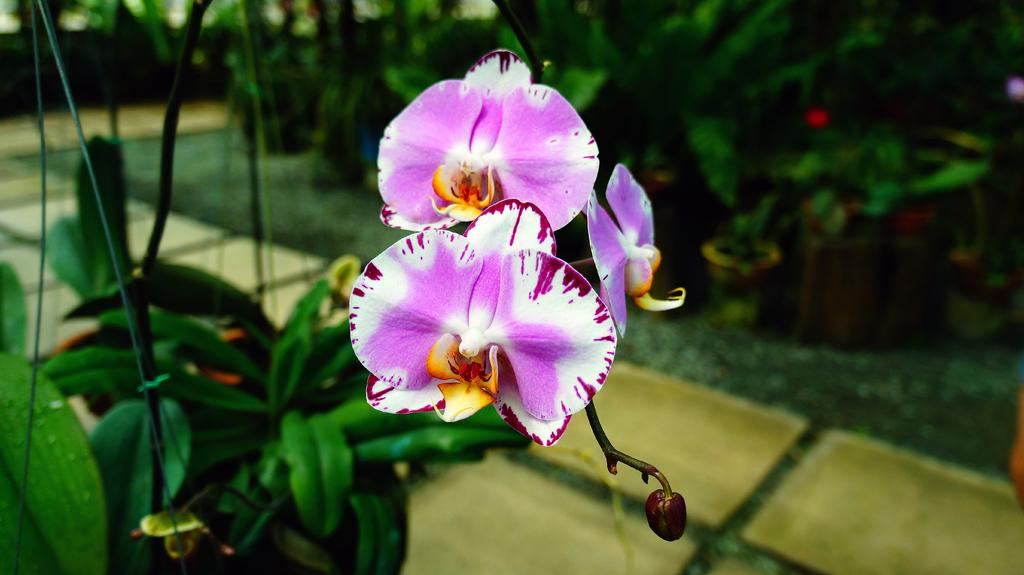What type of plant life can be seen in the image? There are flowers, buds, and leaves in the image. Can you describe the stage of growth for the plants in the image? The image shows both flowers and buds, indicating that some plants are in bloom while others are still growing. What is the background of the image like? The background of the image is blurry. What type of wheel can be seen in the image? There is no wheel present in the image; it features flowers, buds, and leaves. What kind of cream is being used to decorate the plants in the image? There is no cream or decoration present on the plants in the image. 